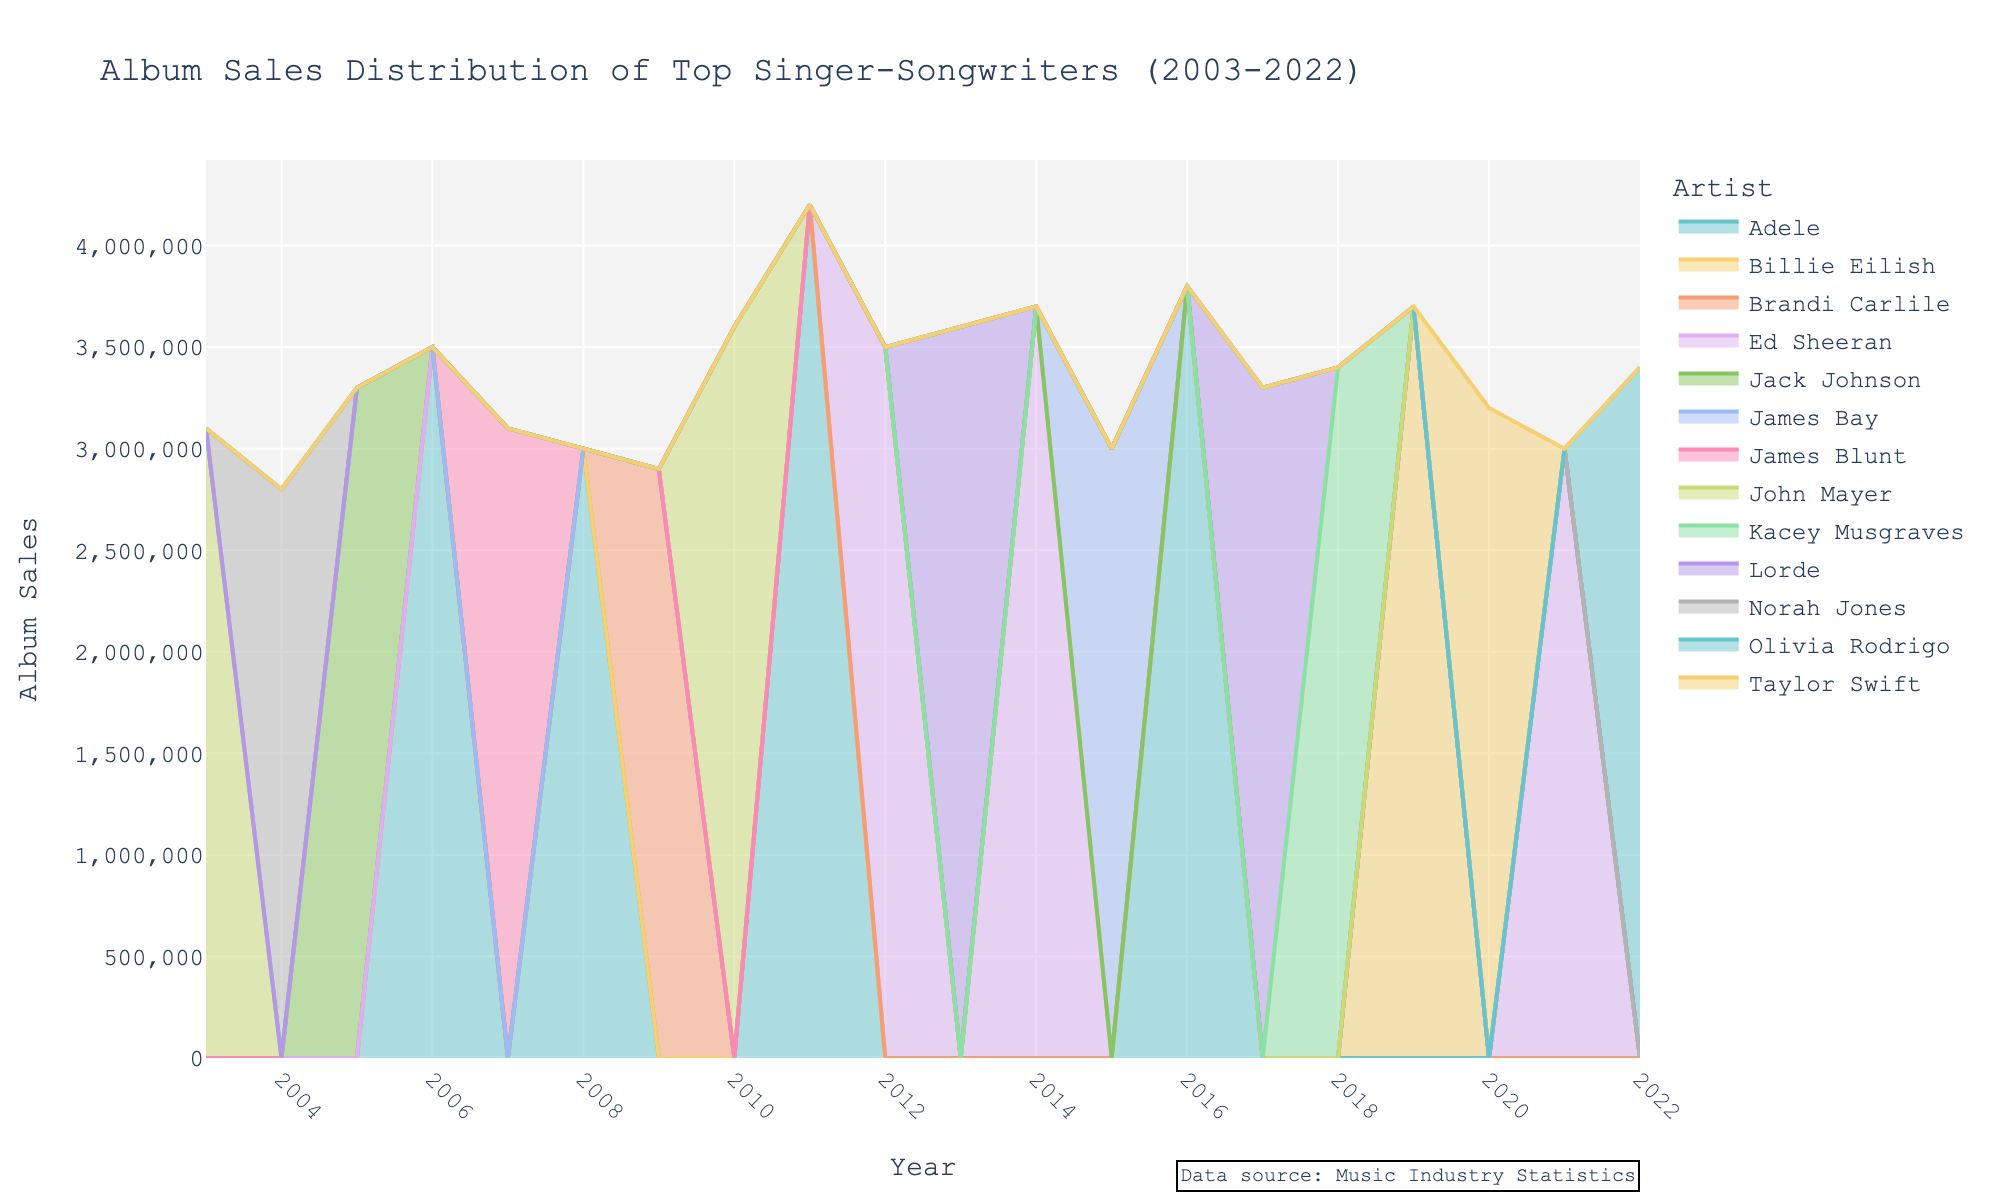What is the title of the figure? The title of the figure is usually displayed at the top and summarizes the main focus of the chart. In this figure, it is directly stated and easy to identify.
Answer: Album Sales Distribution of Top Singer-Songwriters (2003-2022) Which artist had the highest album sales in a single year? To find this, look at the peak values for each artist within the figure's area chart. The highest peak represents the highest sales in a single year. Specifically, you can see that Adele's sales in 2011 are the highest.
Answer: Adele in 2011 How do album sales in 2010 compare between John Mayer and Brandi Carlile? Find the horizontal line at the year 2010 and compare the heights of the shaded areas for John Mayer and Brandi Carlile. John Mayer has a noticeable peak in 2010, whereas there are no sales shown for Brandi Carlile in that year.
Answer: Higher for John Mayer During which year did Ed Sheeran have the second highest album sales? By looking at the peaks for Ed Sheeran over the years, identify the two highest points. The highest is in 2014, and the second highest is in 2012.
Answer: 2012 What is the total album sales for Adele over the span of the graph? Add the album sales values for Adele in all the given years she has data. These years are 2006, 2008, 2011, and 2016. Summing them up: 3500000 + 3000000 + 4200000 + 3800000.
Answer: 14500000 Which year had the lowest total album sales across all artists? To find the lowest total, sum up the sales values for all artists for each year and compare them. 2009 has noticeably lower heights in the chart compared to other years.
Answer: 2009 How does Adele's album sales in 2008 compare with Taylor Swift's in 2020? Identify the areas representing the sales for Adele in 2008 and Taylor Swift in 2020. Adele's height in 2008 is higher compared to Taylor Swift's in 2020.
Answer: Higher for Adele in 2008 Which two artists have overlapping peaks in album sales in any year? Look for instances where the shaded areas for two different artists have peaks that overlap. An example is John Mayer and Brandi Carlile in 2009.
Answer: John Mayer and Brandi Carlile How many artists are represented in the figure? Count the distinct names in the legend or the unique colors/shaded areas in the plot. There are visibly distinct sections for each artist listed.
Answer: 10 artists What’s the average album sales for John Mayer across all his mentioned years? To find the average, sum the album sales values for John Mayer over the years 2003 and 2010, then divide by the number of years he appears. (3100000 + 3600000) / 2.
Answer: 3350000 